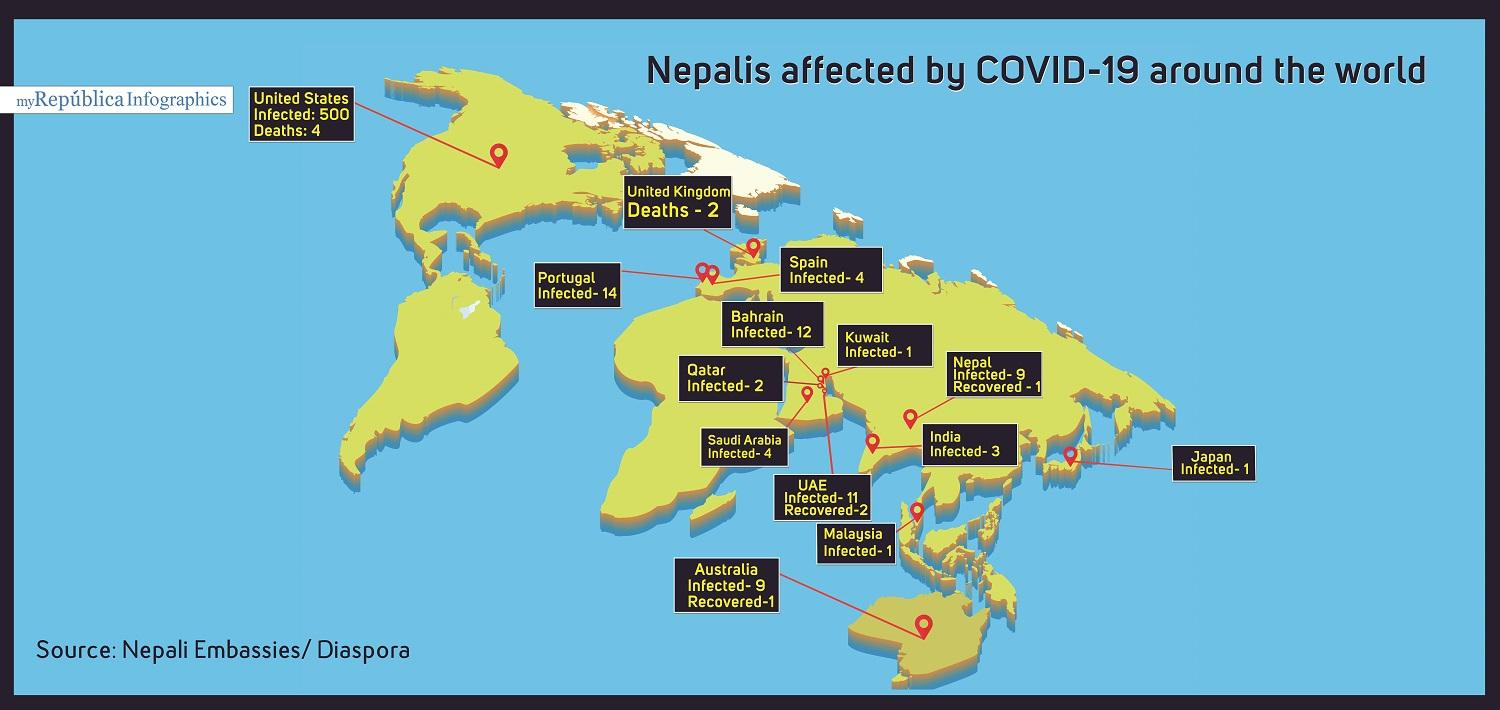List a handful of essential elements in this visual. Recoveries of Nepalis have been reported in Nepal, Australia, and the UAE. Deaths of Nepalis have been reported in the United Kingdom and the United States. The total number of reported deaths of Nepalis is 6. In Japan, Malaysia, and Kuwait, there is only a single Nepali who has been infested. 